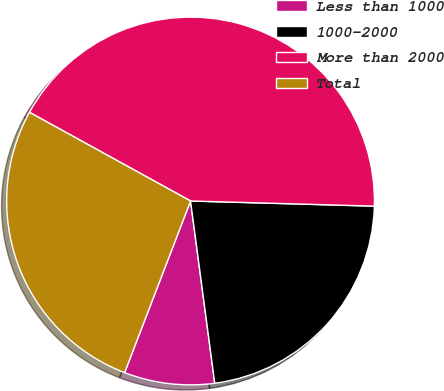<chart> <loc_0><loc_0><loc_500><loc_500><pie_chart><fcel>Less than 1000<fcel>1000-2000<fcel>More than 2000<fcel>Total<nl><fcel>7.94%<fcel>22.45%<fcel>42.44%<fcel>27.17%<nl></chart> 